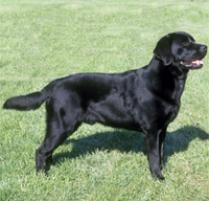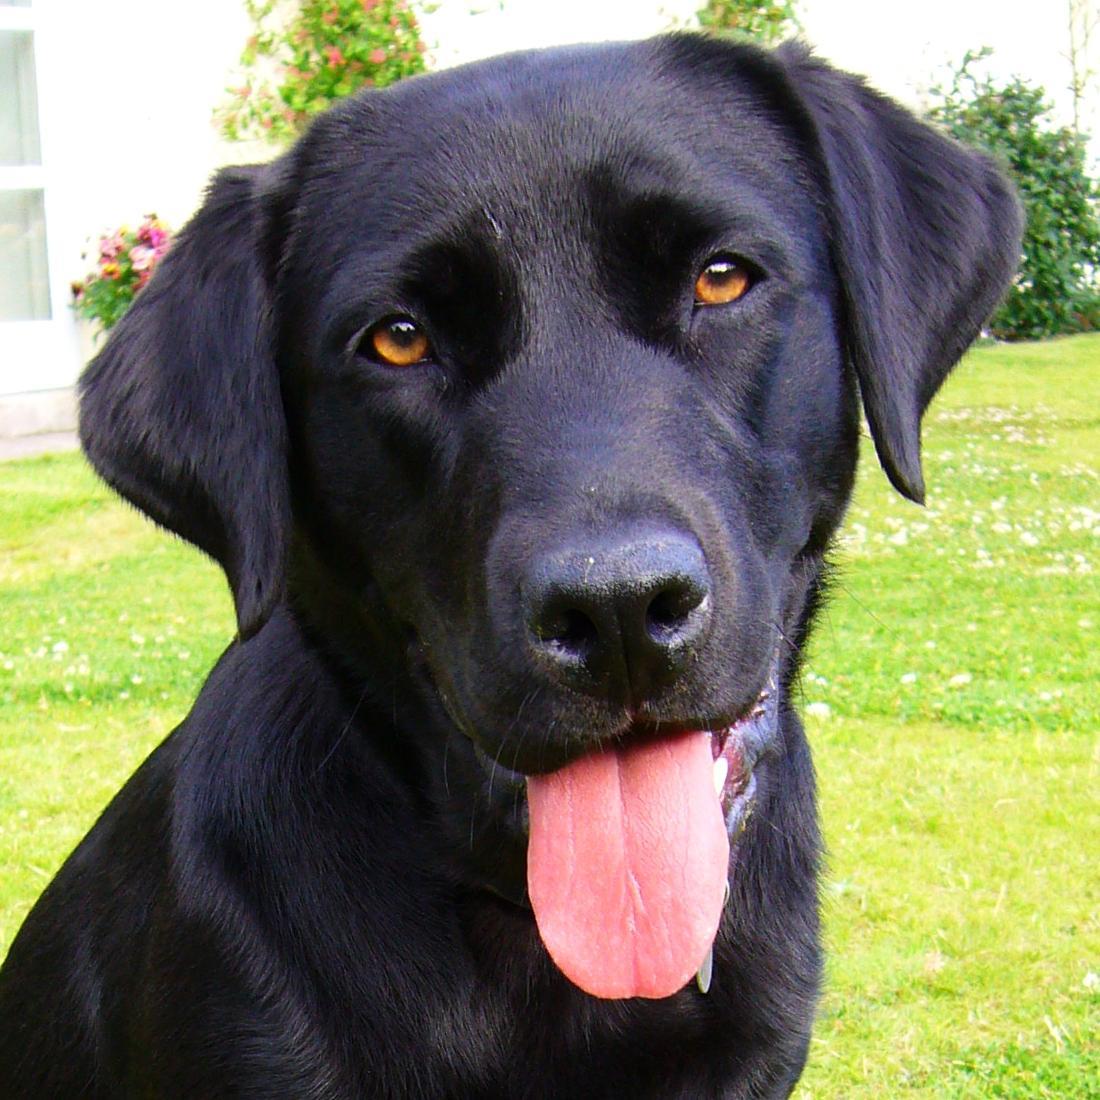The first image is the image on the left, the second image is the image on the right. Analyze the images presented: Is the assertion "A dog is standing and facing left." valid? Answer yes or no. No. 